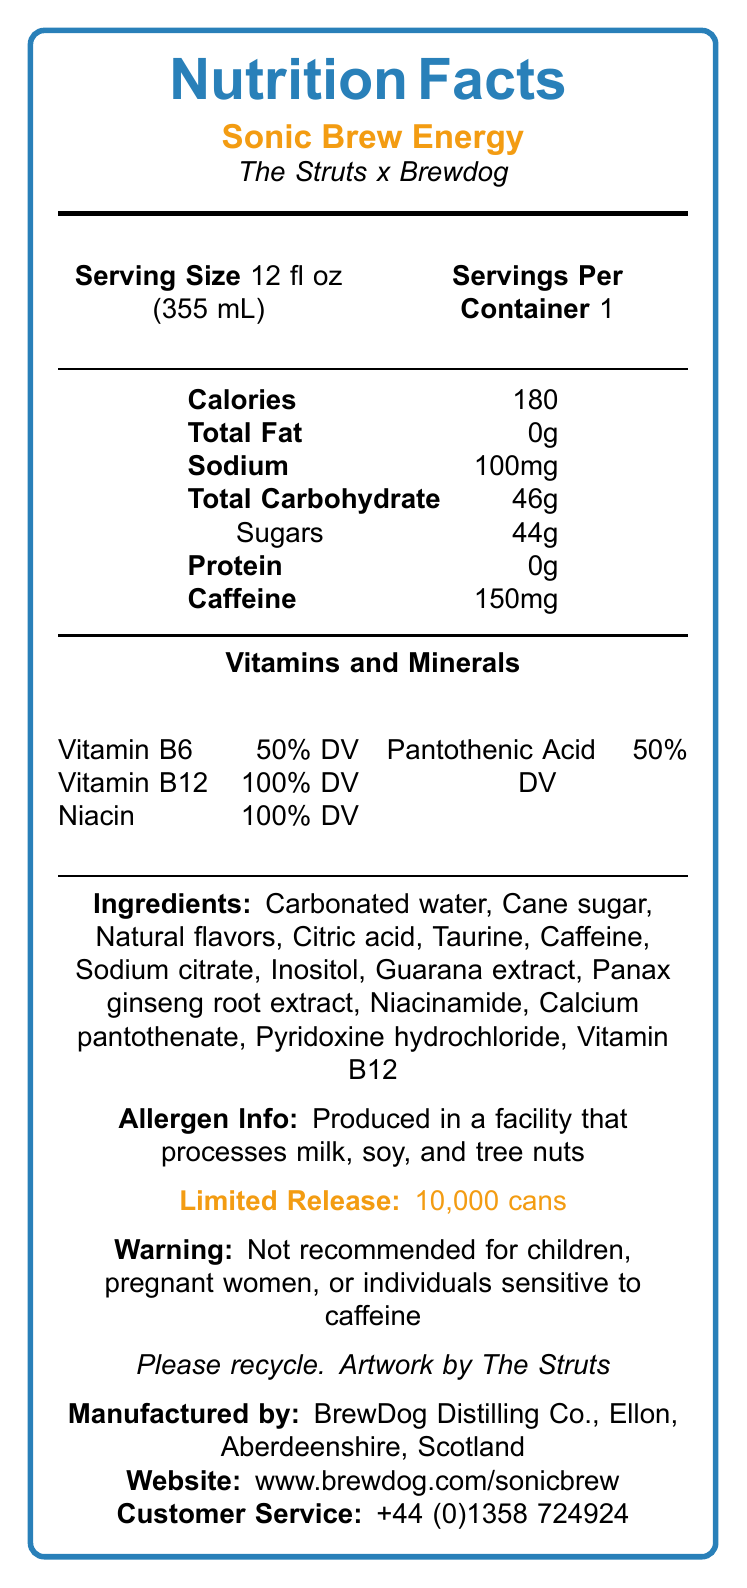What is the serving size of Sonic Brew Energy? The serving size is clearly labeled as "Serving Size: 12 fl oz (355 mL)" in the document.
Answer: 12 fl oz (355 mL) How many calories are in a serving of Sonic Brew Energy? The calories are listed in the tabular section under "Calories."
Answer: 180 What percentage of daily value does Vitamin B12 provide? The document lists "Vitamin B12  100% DV" indicating the daily value provided by the vitamin.
Answer: 100% Which ingredients in the Sonic Brew Energy are specifically mentioned as natural? The ingredients list includes "Natural flavors," which implies these are natural.
Answer: Natural flavors Is Sonic Brew Energy recommended for children or pregnant women? The document has a warning statement saying, "Not recommended for children, pregnant women, or individuals sensitive to caffeine."
Answer: No What is the total amount of sugars in one serving of Sonic Brew Energy? A. 40g B. 44g C. 46g D. 50g The document states "Sugars  44g" under the "Total Carbohydrate" section.
Answer: B Which marketing claim is NOT made about Sonic Brew Energy? I. Supports mental focus and physical performance II. Contains artificial colors III. Crafted with premium ingredients The document includes marketing claims such as "Supports mental focus and physical performance" and "Crafted with premium ingredients" but specifically states "No artificial colors or preservatives."
Answer: II. Contains artificial colors Is the Sonic Brew Energy produced in a facility that might process tree nuts? The allergen information mentions that it is "Produced in a facility that processes milk, soy, and tree nuts."
Answer: Yes Summarize the main idea of the document. The document provides detailed nutritional information, ingredients, allergen warnings, and special features about the Sonic Brew Energy drink, emphasizing its collaborative creation and limited release.
Answer: Sonic Brew Energy is a limited-edition energy drink collaboration between the band The Struts and brewery BrewDog, featuring a unique flavor profile, high caffeine content, various vitamins, and natural ingredients. It includes a distinct can design and fan engagement elements but has concerns regarding quality control and market reach. How much caffeine does one serving of Sonic Brew Energy contain? The amount of caffeine is listed as "Caffeine: 150mg."
Answer: 150mg Where is the manufacturer of Sonic Brew Energy located? The company information section states the manufacturer as "BrewDog Distilling Co., Ellon, Aberdeenshire, Scotland."
Answer: Ellon, Aberdeenshire, Scotland What is the primary demographic target for Sonic Brew Energy according to its marketing claims? The marketing claims suggest it is ideal for supporting mental focus and physical performance and perfect for late-night activities, indicating a target towards active individuals.
Answer: People looking for support in mental focus and physical performance, perfect for late-night gigs and studio sessions. What is the distribution limit for Sonic Brew Energy? The document mentions "Limited release: 10,000 cans."
Answer: 10,000 cans Does the document specify the price of Sonic Brew Energy? The document does not include any pricing information.
Answer: Cannot be determined Which vitamins and minerals provide 50% of the daily value? Both Vitamin B6 and Pantothenic Acid are listed with "50% DV."
Answer: Vitamin B6 and Pantothenic Acid What concern might an executive have regarding quality control? The document mentions that "Small batch production may lead to inconsistencies" under quality control concerns.
Answer: Small batch production may lead to inconsistencies 